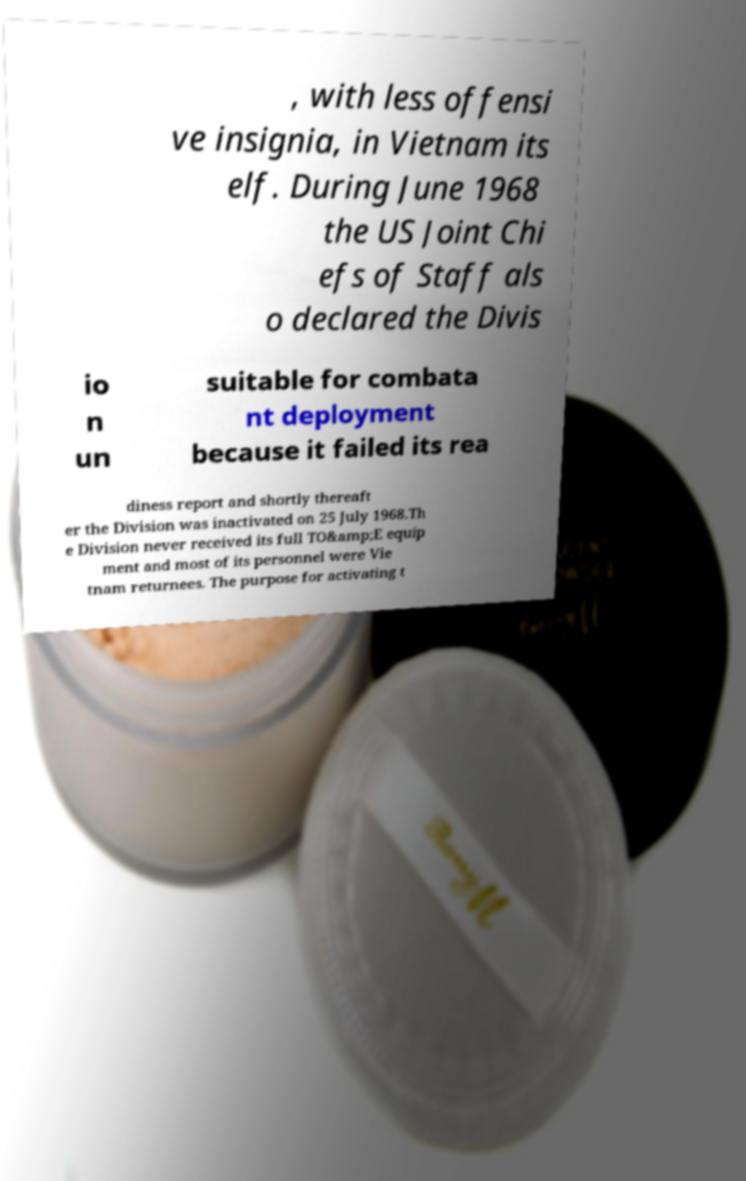For documentation purposes, I need the text within this image transcribed. Could you provide that? , with less offensi ve insignia, in Vietnam its elf. During June 1968 the US Joint Chi efs of Staff als o declared the Divis io n un suitable for combata nt deployment because it failed its rea diness report and shortly thereaft er the Division was inactivated on 25 July 1968.Th e Division never received its full TO&amp;E equip ment and most of its personnel were Vie tnam returnees. The purpose for activating t 